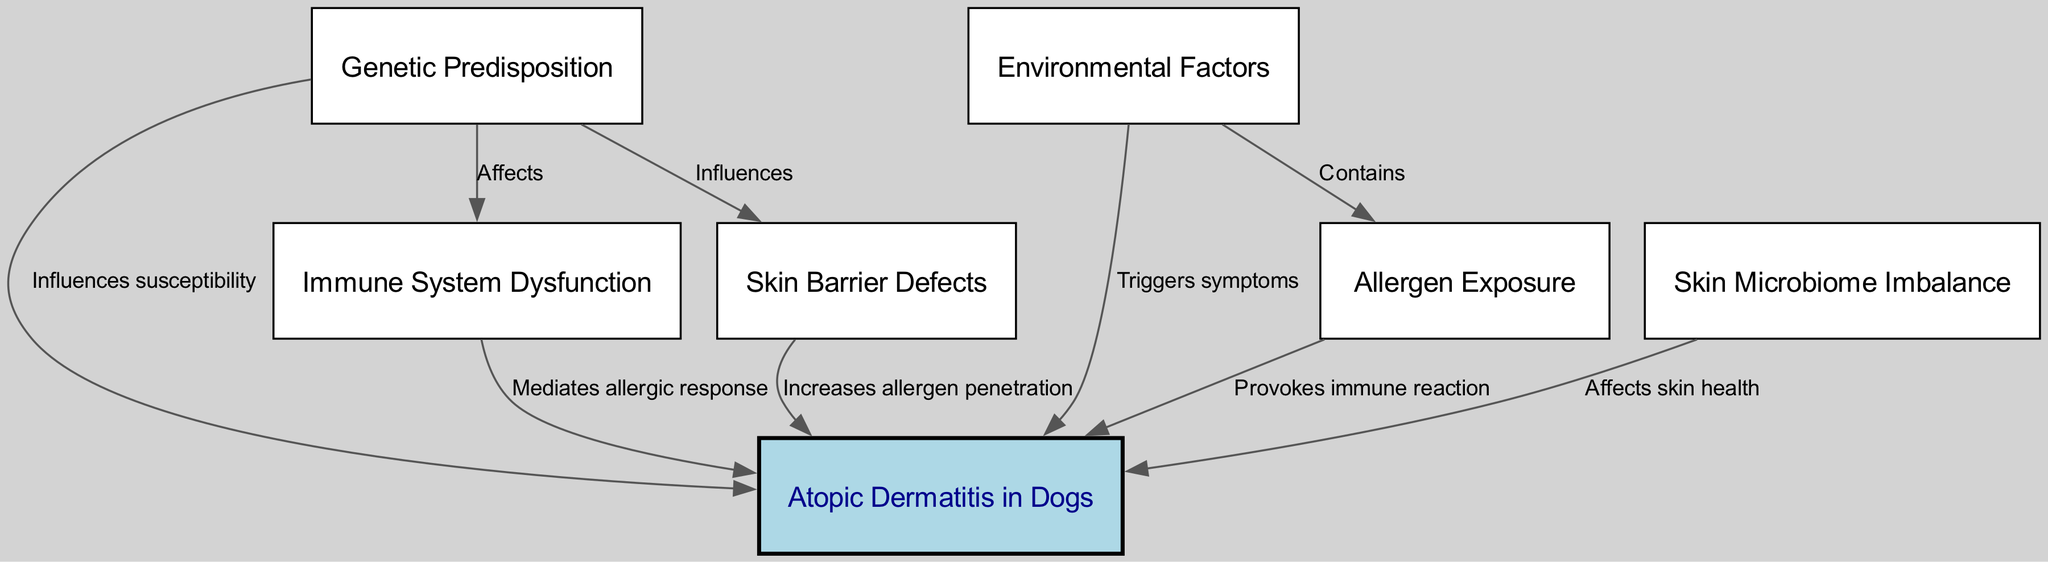What is the central topic of the diagram? The central topic is located at the top of the diagram and is labeled "Atopic Dermatitis in Dogs".
Answer: Atopic Dermatitis in Dogs How many nodes are in the concept map? By counting all the distinct nodes presented in the diagram, there are a total of 7 nodes.
Answer: 7 Which factor influences the skin barrier? The diagram indicates that "Genetic Predisposition" influences the "Skin Barrier Defects".
Answer: Genetic Predisposition What role does the immune system play in atopic dermatitis? The diagram describes that the "Immune System Dysfunction" mediates the allergic response in relation to atopic dermatitis.
Answer: Mediates allergic response What do "Allergens" provoke in atopic dermatitis? According to the diagram, "Allergens" provoke an "immune reaction" in the context of atopic dermatitis.
Answer: Immune reaction What is the relationship between environmental factors and allergens? The diagram shows that "Environmental Factors" contain "Allergens", indicating a direct connection.
Answer: Contains How does skin microbiome imbalance affect atopic dermatitis? The diagram states that "Skin Microbiome Imbalance" affects "skin health", implying it has a role in the overall condition.
Answer: Affects skin health Which factor triggers symptoms of atopic dermatitis? "Environmental Factors" are identified in the diagram as the element that triggers symptoms of atopic dermatitis.
Answer: Triggers symptoms How does genetics affect the immune system in relation to atopic dermatitis? The diagram illustrates that "Genetic Predisposition" affects the "Immune System Dysfunction", indicating a link between these factors.
Answer: Affects 